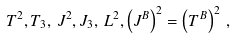Convert formula to latex. <formula><loc_0><loc_0><loc_500><loc_500>T ^ { 2 } , T _ { 3 } , \, J ^ { 2 } , J _ { 3 } , \, L ^ { 2 } , \left ( J ^ { B } \right ) ^ { 2 } = \left ( T ^ { B } \right ) ^ { 2 } \, ,</formula> 